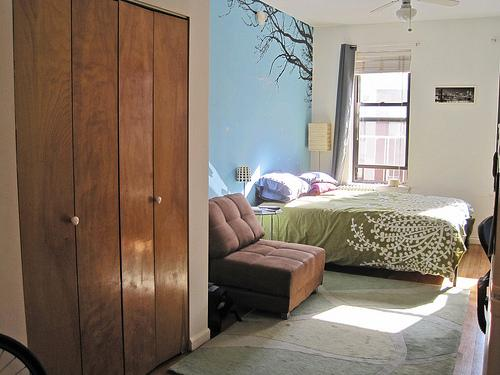What type of picture can be seen hanging on the wall, and where is it positioned? A black and white picture is hanging on the wall next to the window. Can you tell me how many stacks of pillows are on the bed and their colors? There are two stacks of pillows on the bed, with purple and pink colors. Identify the fan in the image and describe its position. There is a ceiling fan with a lamp located above the bed. What is the color of the wall behind the bed, and what decoration is on it? The wall behind the bed is blue and has a tree decoration on it. List any furniture located close to the bed. A brown chair and a circular side table with a lamp on it can be found by the bed. How many lamps are visible in the image and describe their shades. There are three lamps in the image, having square, cream-colored, and polka dot-designed shades. Please provide details about the closet and any notable features on it. The closet is a four-door wooden closet with brown doors and two small knobs on each door. Describe the window and its related features in this image. The window is slightly open with a gray curtain, and there's a lamp with a square shade close to it. In the image, what type of floor can be seen and what else is on the floor? The image has a hardwood floor with a gray and white colored rug placed on it. What object is located in the corner of the image and what is its function? A wheel of a bicycle is located in the corner, which is part of the bicycle's movement mechanism. 